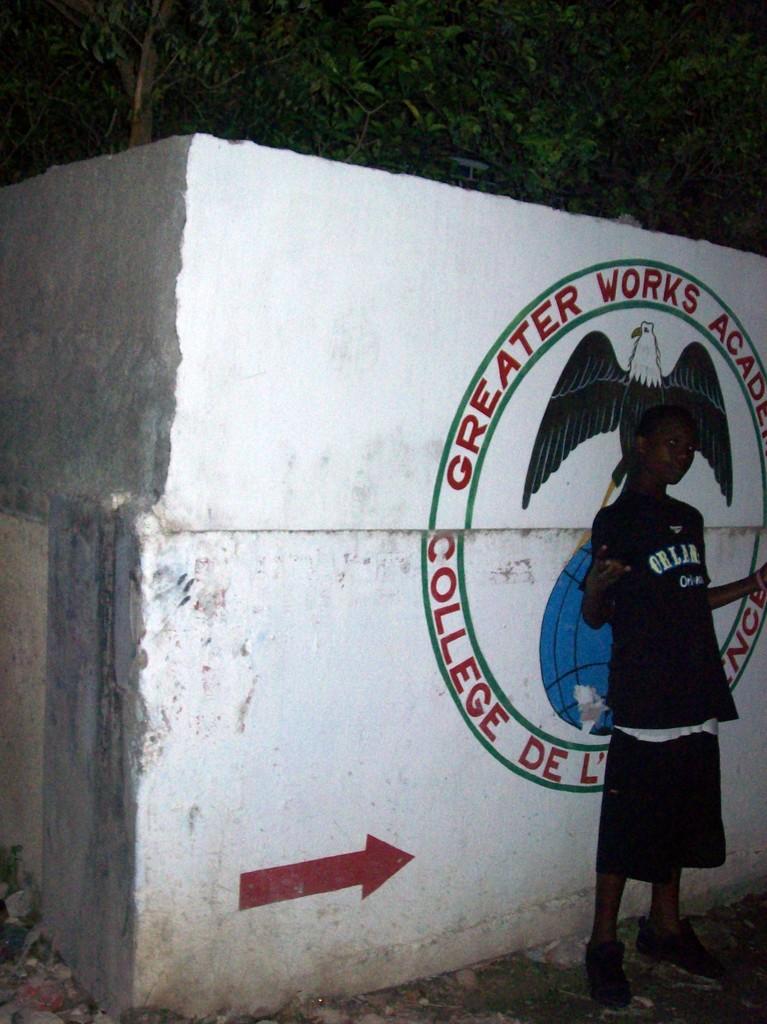What is the name of the academy?
Provide a short and direct response. Greater works academy. 